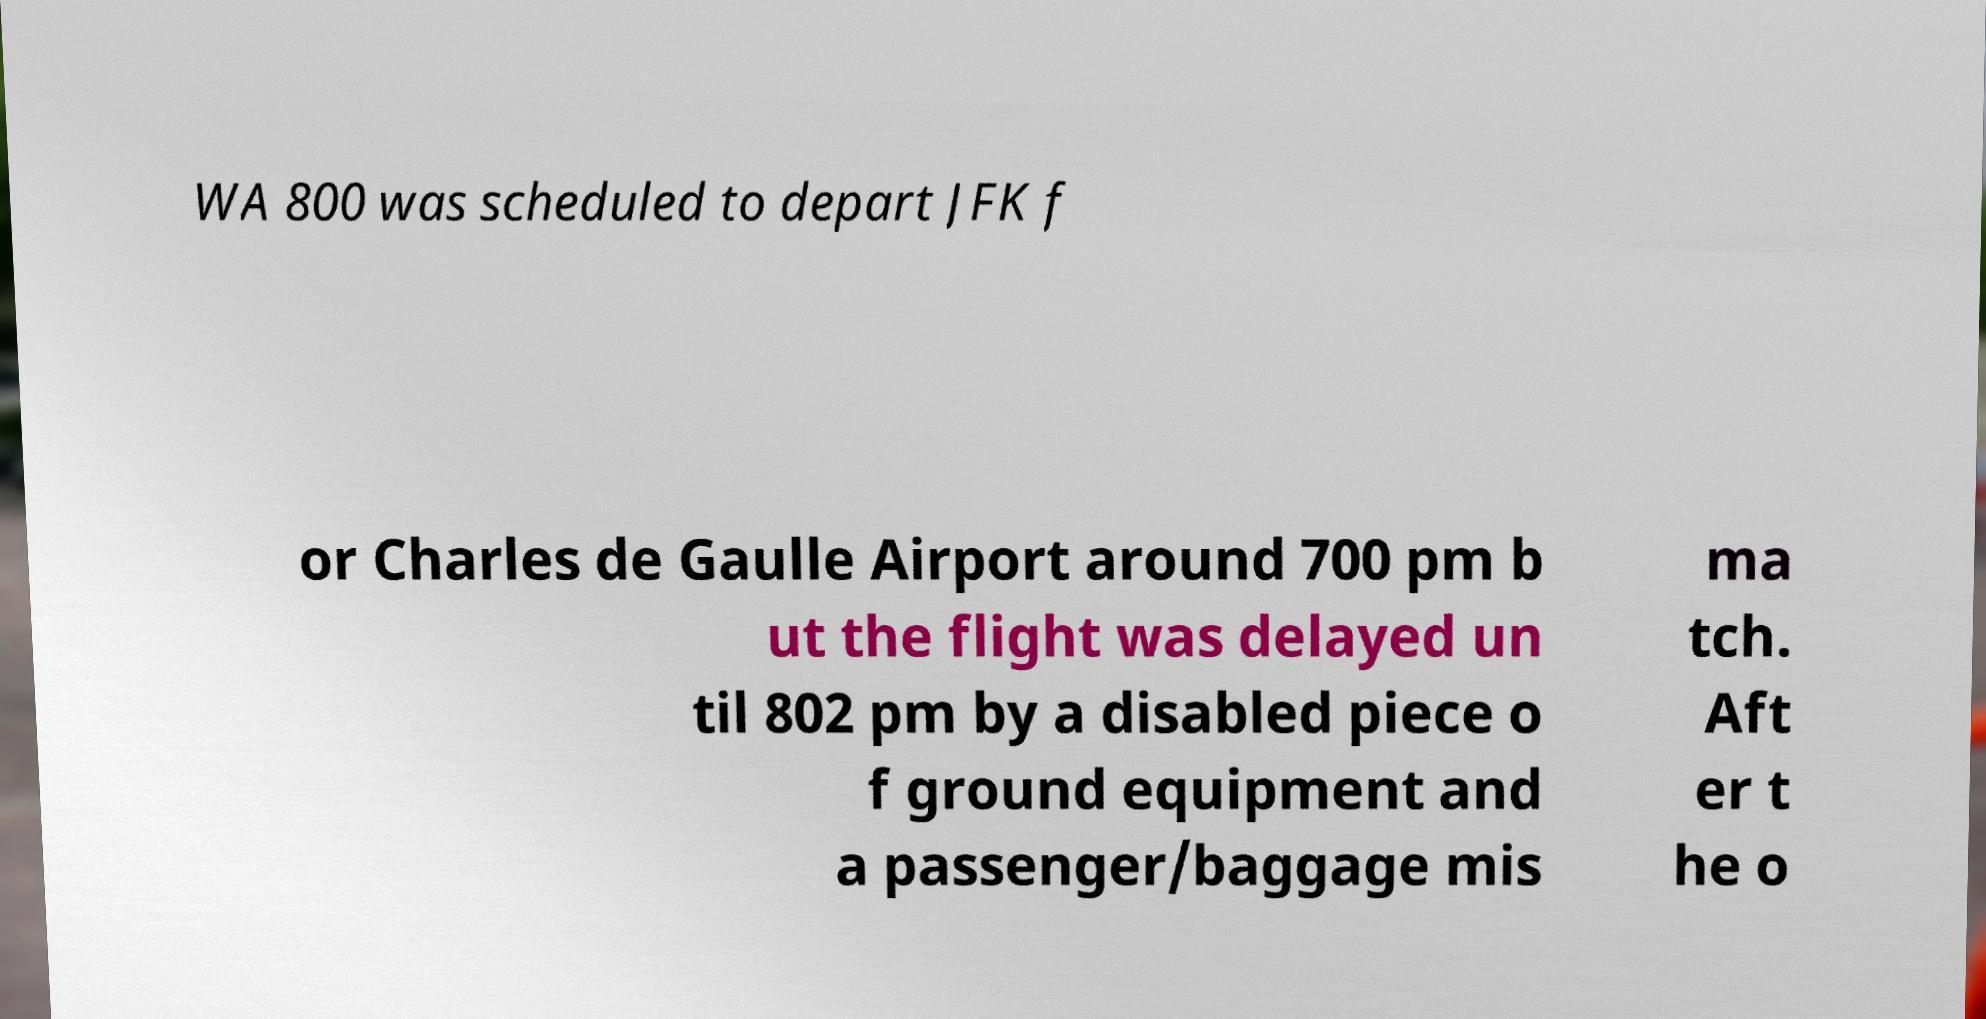Can you read and provide the text displayed in the image?This photo seems to have some interesting text. Can you extract and type it out for me? WA 800 was scheduled to depart JFK f or Charles de Gaulle Airport around 700 pm b ut the flight was delayed un til 802 pm by a disabled piece o f ground equipment and a passenger/baggage mis ma tch. Aft er t he o 